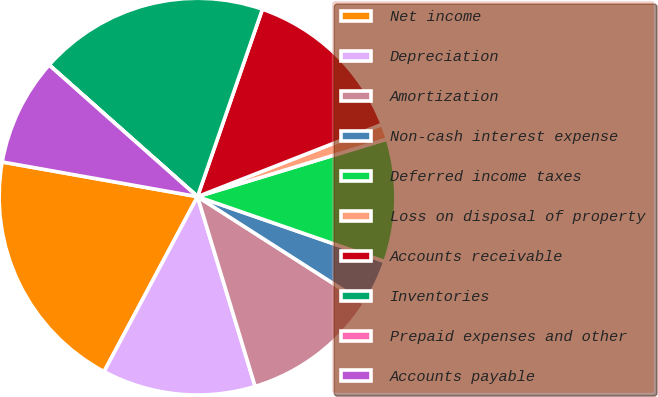Convert chart to OTSL. <chart><loc_0><loc_0><loc_500><loc_500><pie_chart><fcel>Net income<fcel>Depreciation<fcel>Amortization<fcel>Non-cash interest expense<fcel>Deferred income taxes<fcel>Loss on disposal of property<fcel>Accounts receivable<fcel>Inventories<fcel>Prepaid expenses and other<fcel>Accounts payable<nl><fcel>19.99%<fcel>12.5%<fcel>11.25%<fcel>3.75%<fcel>10.0%<fcel>1.25%<fcel>13.75%<fcel>18.75%<fcel>0.01%<fcel>8.75%<nl></chart> 